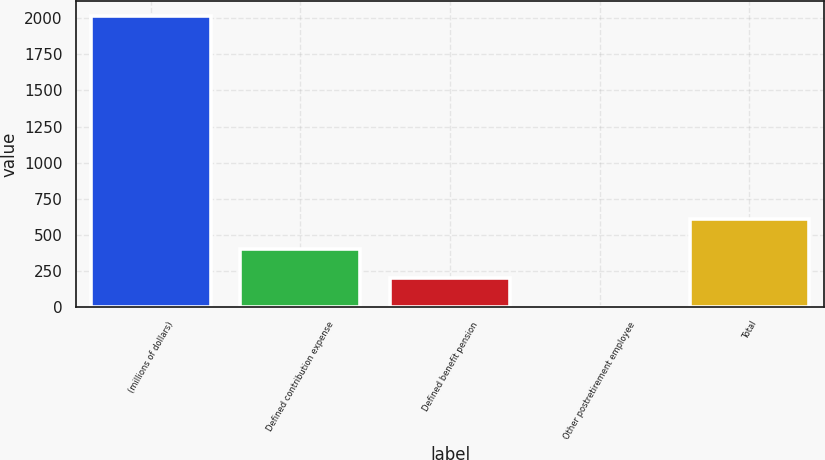<chart> <loc_0><loc_0><loc_500><loc_500><bar_chart><fcel>(millions of dollars)<fcel>Defined contribution expense<fcel>Defined benefit pension<fcel>Other postretirement employee<fcel>Total<nl><fcel>2016<fcel>404.32<fcel>202.86<fcel>1.4<fcel>605.78<nl></chart> 